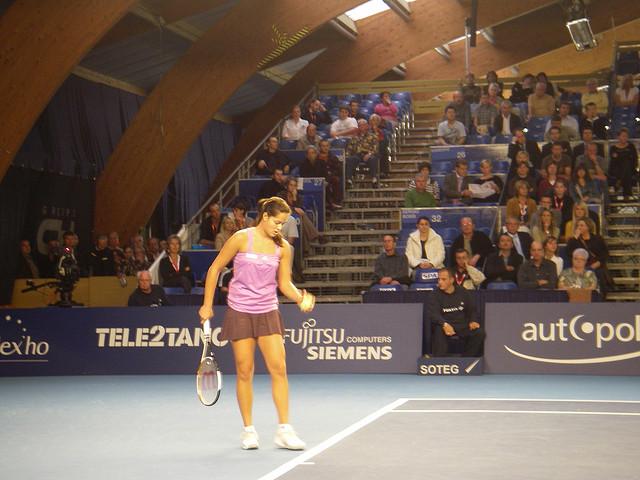What is this person holding?
Concise answer only. Tennis racket. What color is the woman's skirt?
Keep it brief. Black. Where are the audience?
Give a very brief answer. In stands. 